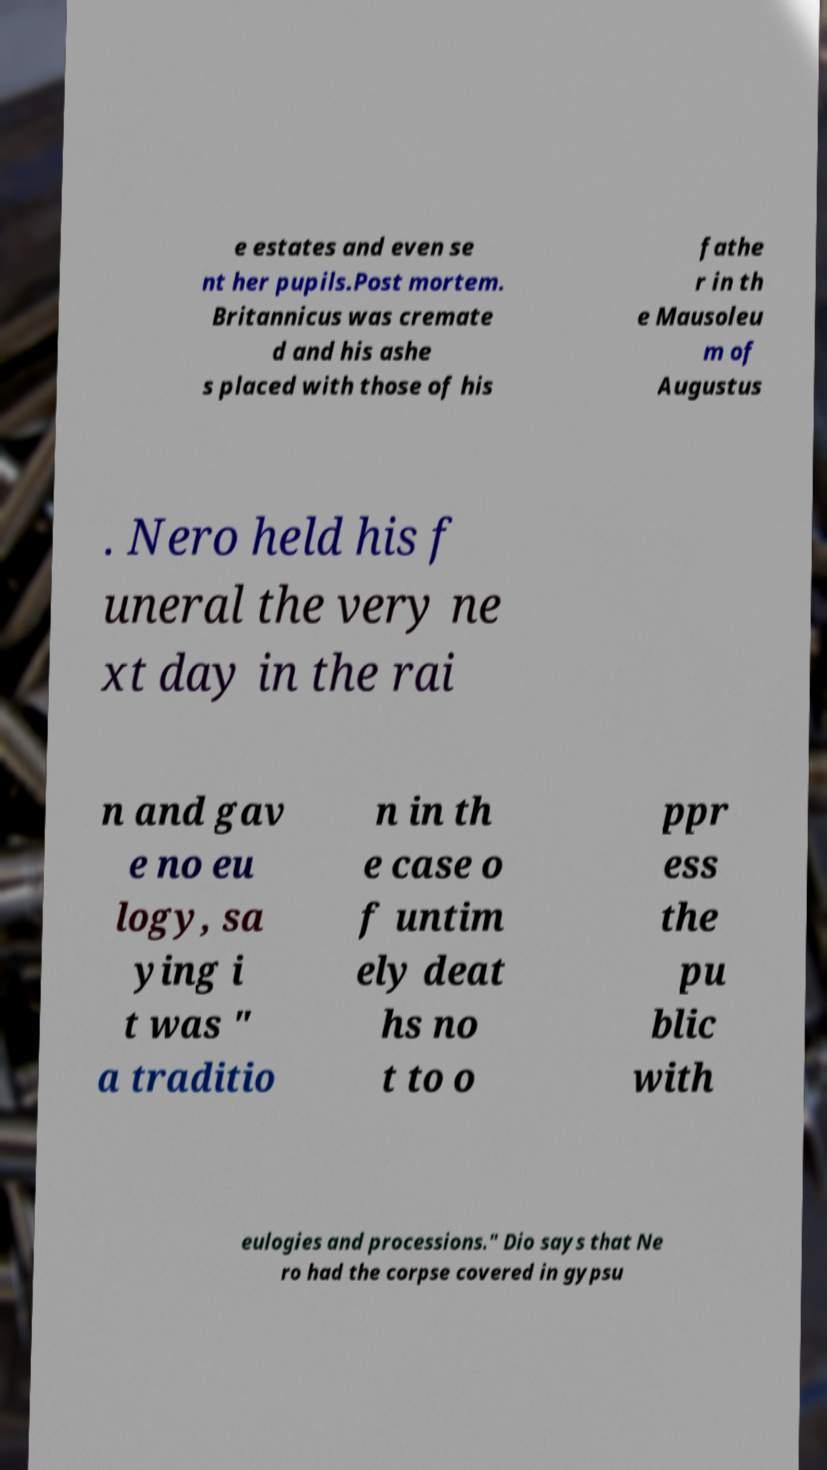Could you assist in decoding the text presented in this image and type it out clearly? e estates and even se nt her pupils.Post mortem. Britannicus was cremate d and his ashe s placed with those of his fathe r in th e Mausoleu m of Augustus . Nero held his f uneral the very ne xt day in the rai n and gav e no eu logy, sa ying i t was " a traditio n in th e case o f untim ely deat hs no t to o ppr ess the pu blic with eulogies and processions." Dio says that Ne ro had the corpse covered in gypsu 